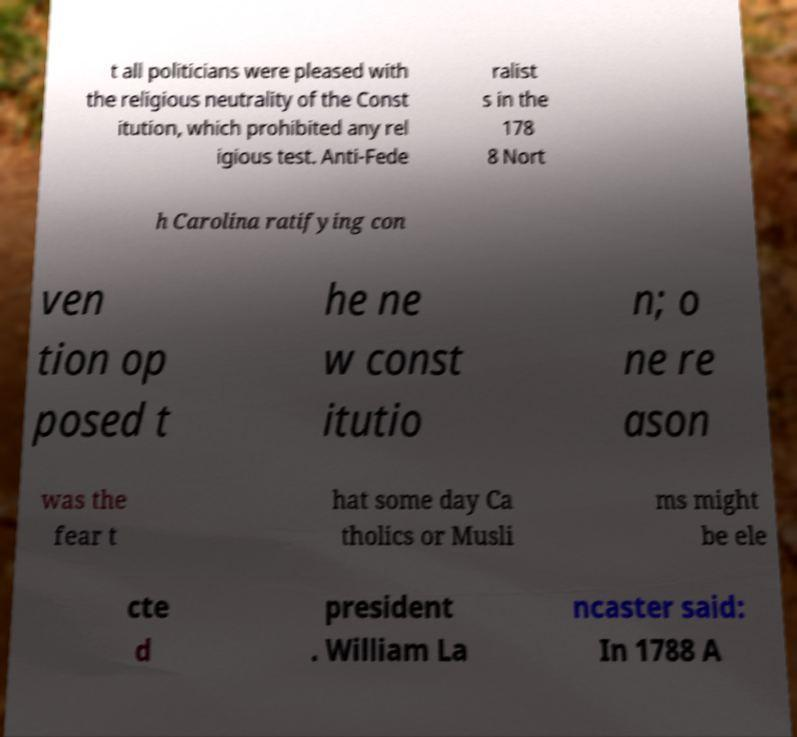Could you extract and type out the text from this image? t all politicians were pleased with the religious neutrality of the Const itution, which prohibited any rel igious test. Anti-Fede ralist s in the 178 8 Nort h Carolina ratifying con ven tion op posed t he ne w const itutio n; o ne re ason was the fear t hat some day Ca tholics or Musli ms might be ele cte d president . William La ncaster said: In 1788 A 